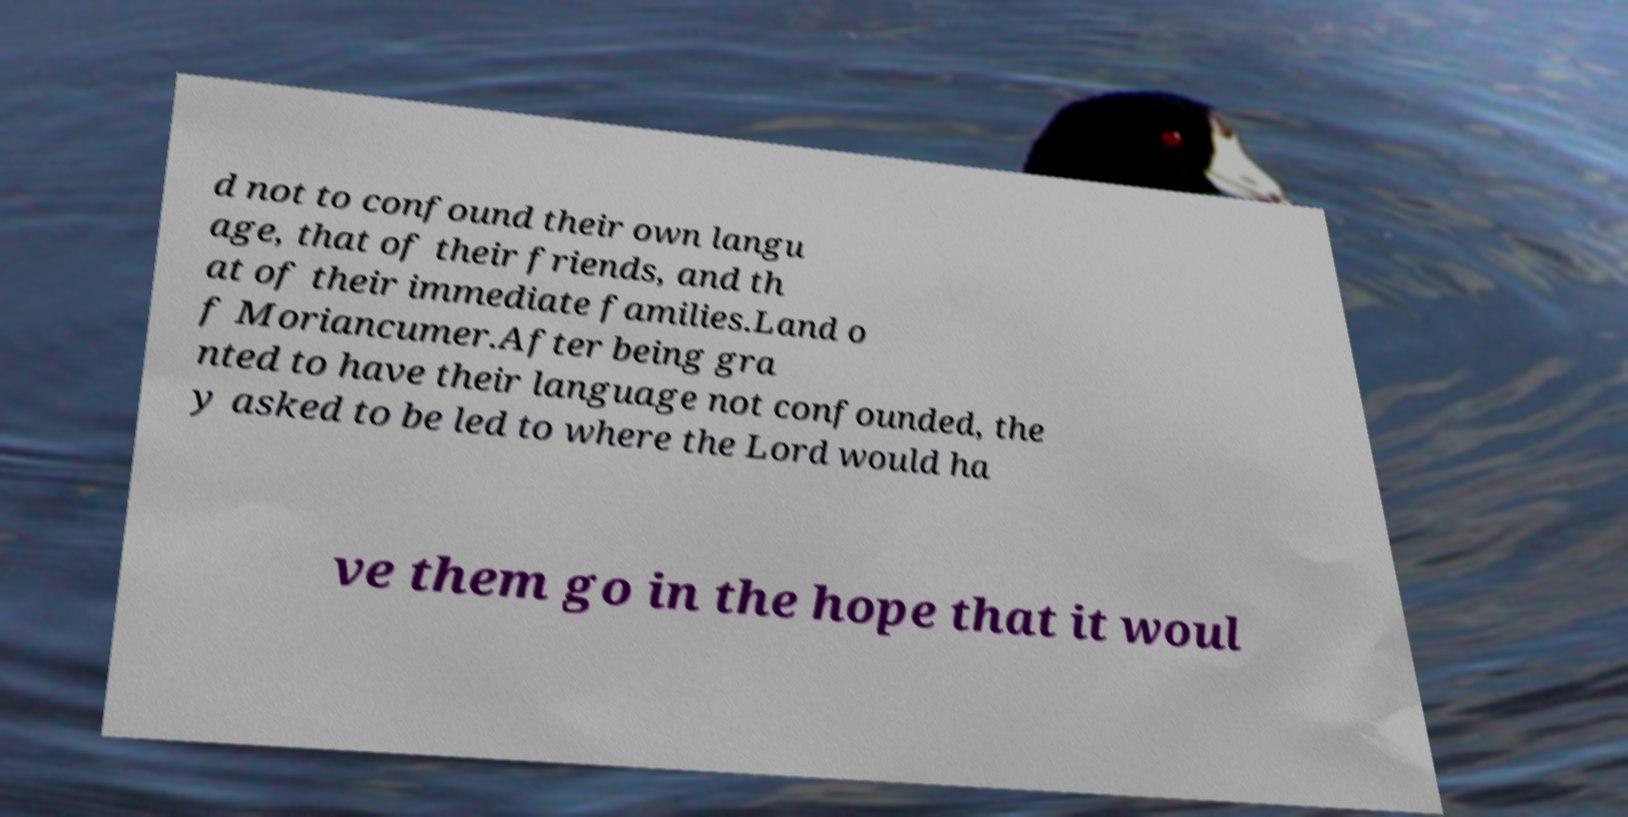Could you assist in decoding the text presented in this image and type it out clearly? d not to confound their own langu age, that of their friends, and th at of their immediate families.Land o f Moriancumer.After being gra nted to have their language not confounded, the y asked to be led to where the Lord would ha ve them go in the hope that it woul 